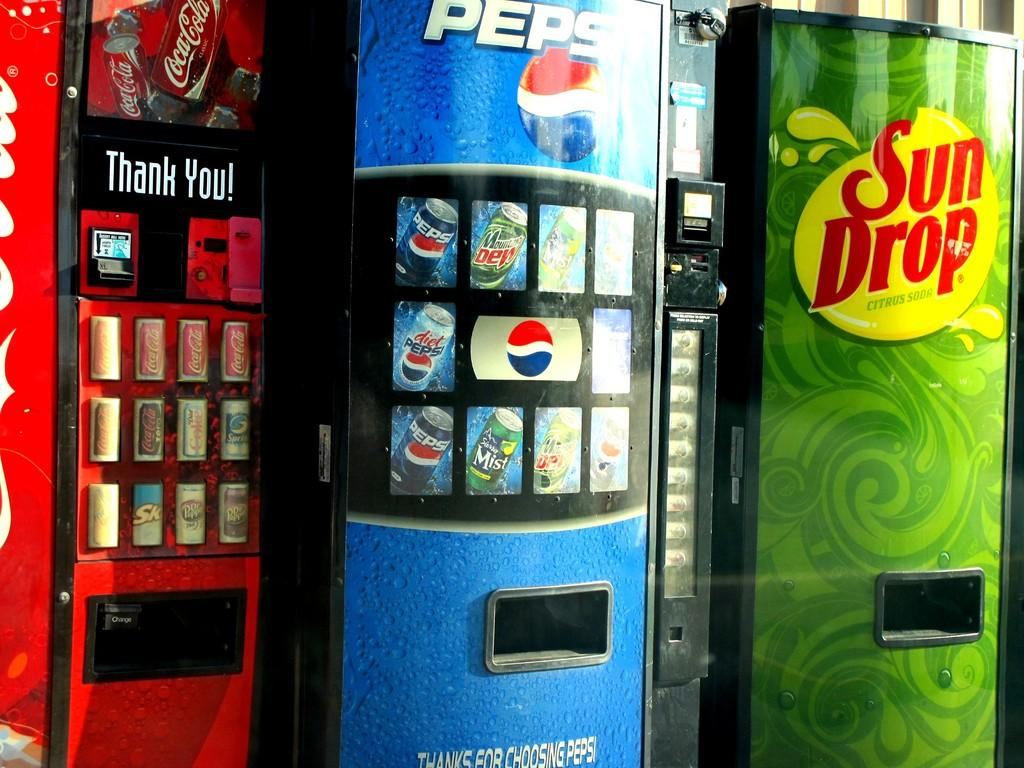Provide a one-sentence caption for the provided image. Coca-Cola, Pepsi, and Sun Drop vending machines are next to each other. 